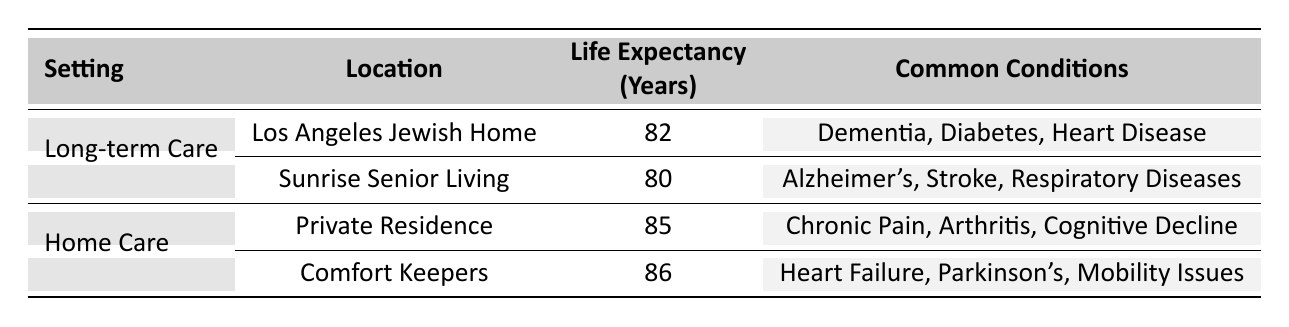What is the average life expectancy in Home Care settings? From the table, we see two Home Care settings: Private Residence with an average life expectancy of 85 years and Comfort Keepers with an average of 86 years. To find the average for Home Care, we add these values: 85 + 86 = 171 and then divide by the number of settings (2), resulting in an average of 171 / 2 = 85.5 years.
Answer: 85.5 Which location has the highest life expectancy in the table? The table lists four settings, comparing Life Expectancy. Comfort Keepers has the highest value at 86 years. Therefore, by examining the values in the Life Expectancy column, we can identify that Comfort Keepers is the location with the highest life expectancy.
Answer: Comfort Keepers Is the average life expectancy in Long-term Care higher than that in Home Care? The average life expectancy for Long-term Care settings is calculated as follows: Los Angeles Jewish Home (82 years) and Sunrise Senior Living (80 years) give us an average of (82 + 80) / 2 = 81 years. For Home Care, we already calculated the average as 85.5 years. Since 81 years is less than 85.5 years, the statement is false.
Answer: No What are the common conditions in Long-term Care at Los Angeles Jewish Home? Referring to the table, for the Los Angeles Jewish Home under Long-term Care, the common conditions listed are Dementia, Diabetes, and Heart Disease. These conditions are specifically noted in the relevant row of the table.
Answer: Dementia, Diabetes, Heart Disease Is there any overlap in common conditions between Long-term Care and Home Care? Checking the common conditions for each care setting, Long-term Care mentions conditions like Dementia and Heart Disease, while Home Care mentions Chronic Pain and Arthritis, listing different conditions altogether. Therefore, there is no overlap in the conditions listed for both settings, making this statement true.
Answer: No 